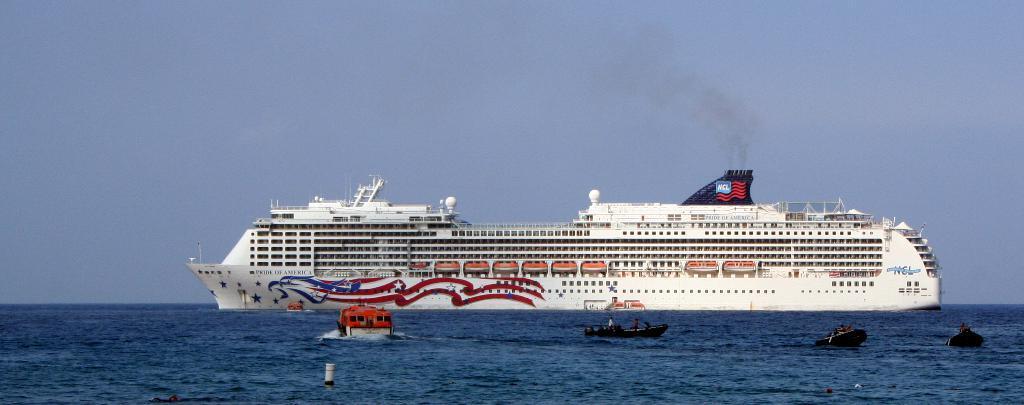In one or two sentences, can you explain what this image depicts? At the bottom of the image there is water. On the water there are boats. There is a ship with railings, windows, poles, rods and also there are chimneys. There are few designs on the ship. And also there is something written on it. At the top of the image there is sky.  